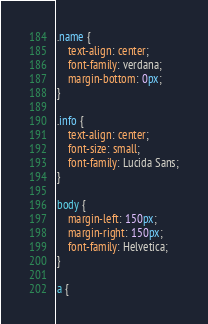Convert code to text. <code><loc_0><loc_0><loc_500><loc_500><_CSS_>.name {
    text-align: center;
    font-family: verdana;
    margin-bottom: 0px;
}

.info {
    text-align: center;
    font-size: small;
    font-family: Lucida Sans;
}

body {
    margin-left: 150px;
    margin-right: 150px;
    font-family: Helvetica;
}

a {</code> 